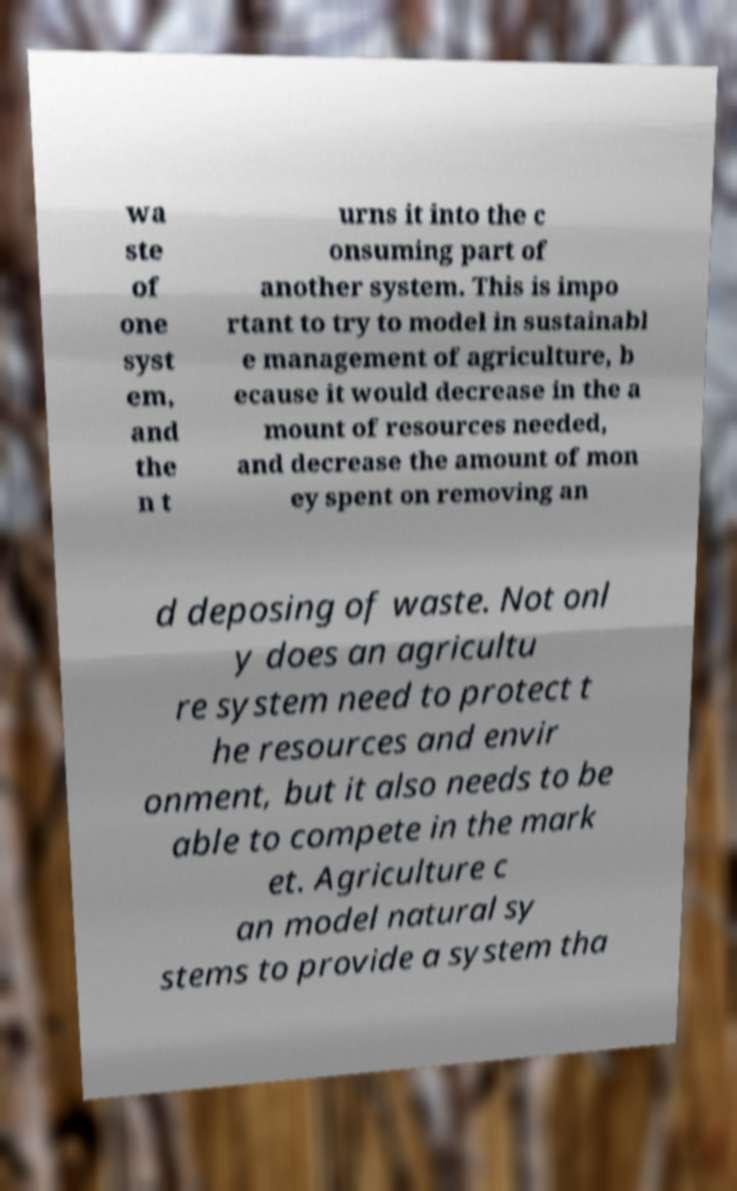Could you extract and type out the text from this image? wa ste of one syst em, and the n t urns it into the c onsuming part of another system. This is impo rtant to try to model in sustainabl e management of agriculture, b ecause it would decrease in the a mount of resources needed, and decrease the amount of mon ey spent on removing an d deposing of waste. Not onl y does an agricultu re system need to protect t he resources and envir onment, but it also needs to be able to compete in the mark et. Agriculture c an model natural sy stems to provide a system tha 